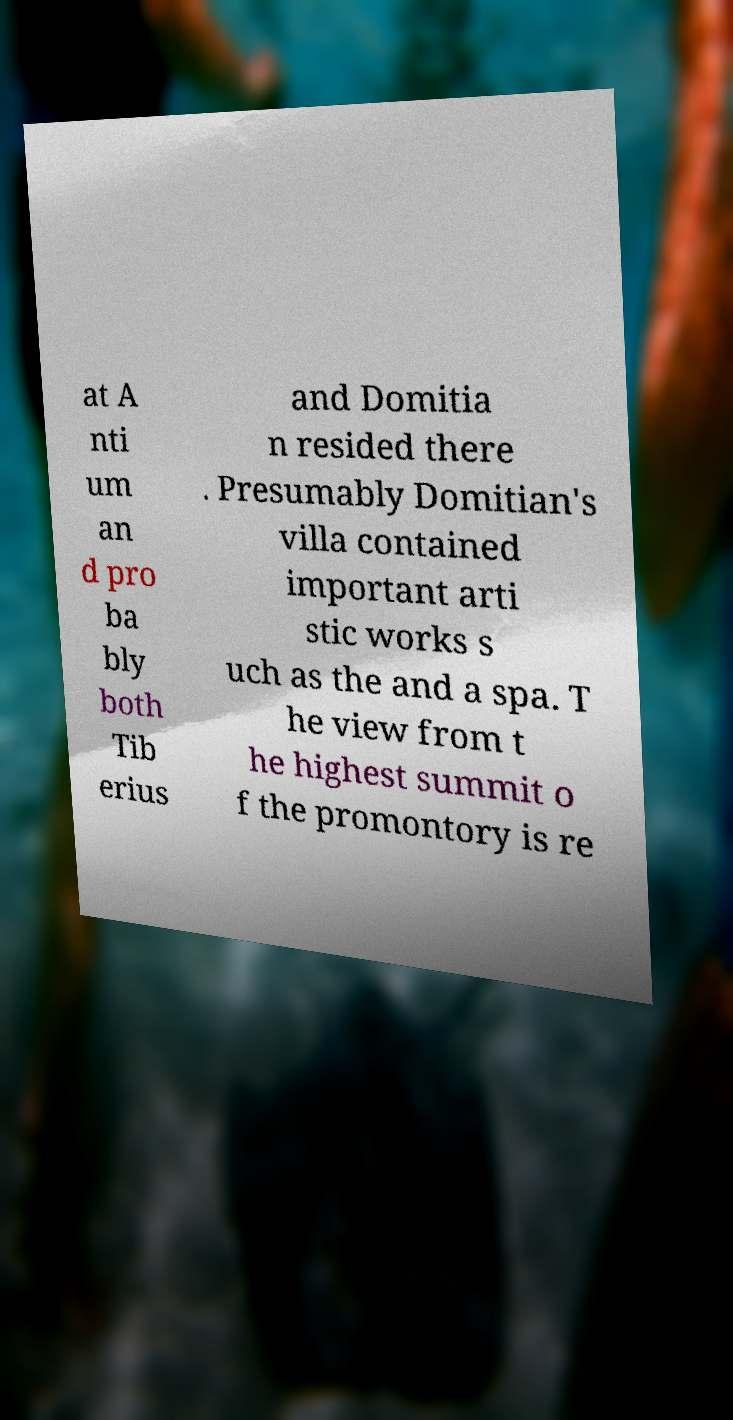For documentation purposes, I need the text within this image transcribed. Could you provide that? at A nti um an d pro ba bly both Tib erius and Domitia n resided there . Presumably Domitian's villa contained important arti stic works s uch as the and a spa. T he view from t he highest summit o f the promontory is re 